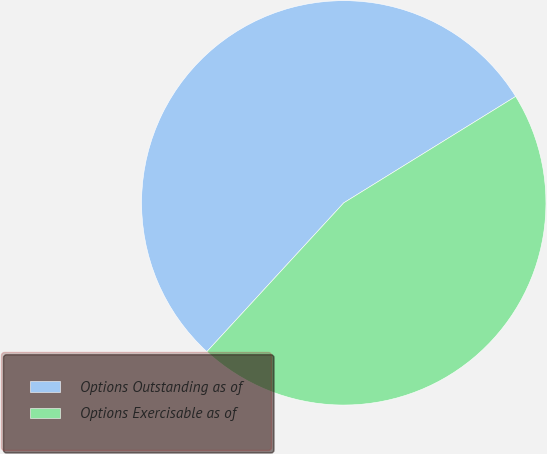Convert chart. <chart><loc_0><loc_0><loc_500><loc_500><pie_chart><fcel>Options Outstanding as of<fcel>Options Exercisable as of<nl><fcel>54.34%<fcel>45.66%<nl></chart> 